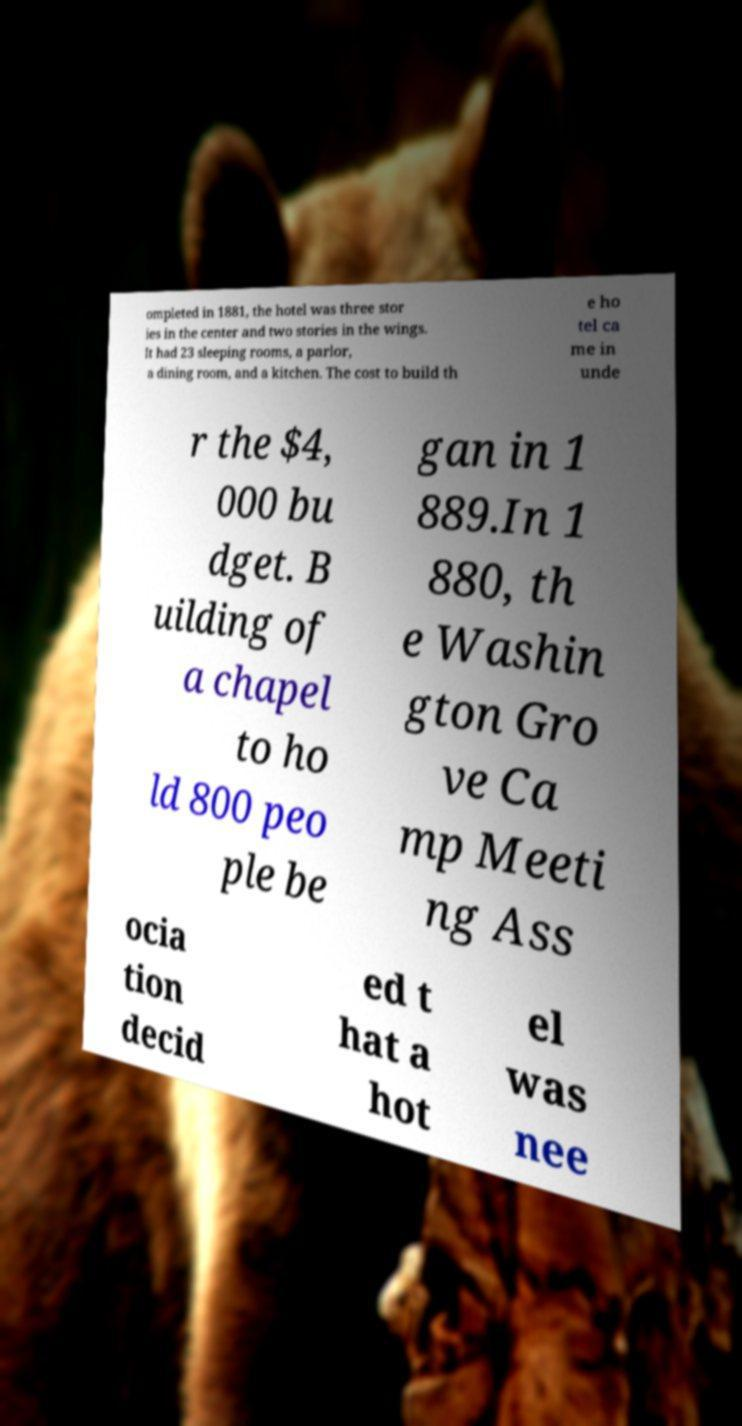What messages or text are displayed in this image? I need them in a readable, typed format. ompleted in 1881, the hotel was three stor ies in the center and two stories in the wings. It had 23 sleeping rooms, a parlor, a dining room, and a kitchen. The cost to build th e ho tel ca me in unde r the $4, 000 bu dget. B uilding of a chapel to ho ld 800 peo ple be gan in 1 889.In 1 880, th e Washin gton Gro ve Ca mp Meeti ng Ass ocia tion decid ed t hat a hot el was nee 